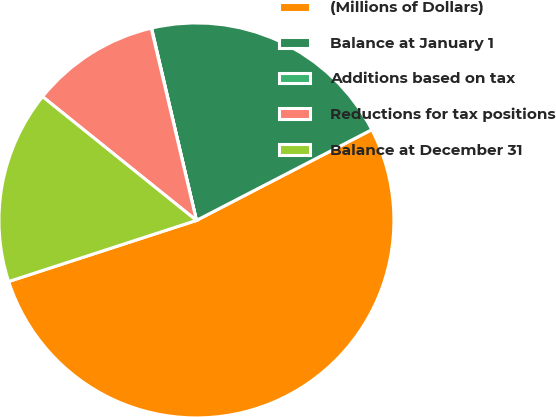Convert chart. <chart><loc_0><loc_0><loc_500><loc_500><pie_chart><fcel>(Millions of Dollars)<fcel>Balance at January 1<fcel>Additions based on tax<fcel>Reductions for tax positions<fcel>Balance at December 31<nl><fcel>52.59%<fcel>21.05%<fcel>0.03%<fcel>10.54%<fcel>15.79%<nl></chart> 